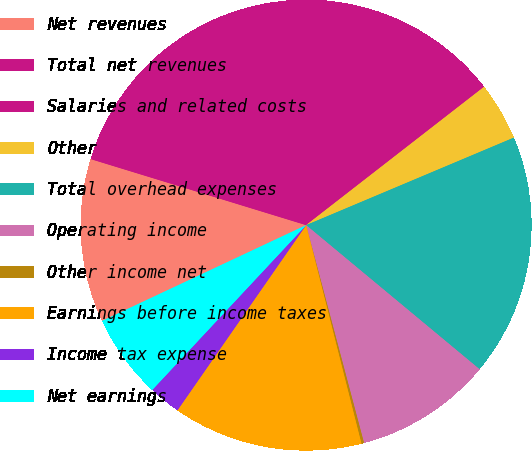Convert chart to OTSL. <chart><loc_0><loc_0><loc_500><loc_500><pie_chart><fcel>Net revenues<fcel>Total net revenues<fcel>Salaries and related costs<fcel>Other<fcel>Total overhead expenses<fcel>Operating income<fcel>Other income net<fcel>Earnings before income taxes<fcel>Income tax expense<fcel>Net earnings<nl><fcel>11.72%<fcel>19.26%<fcel>15.49%<fcel>4.17%<fcel>17.38%<fcel>9.83%<fcel>0.19%<fcel>13.61%<fcel>2.29%<fcel>6.06%<nl></chart> 